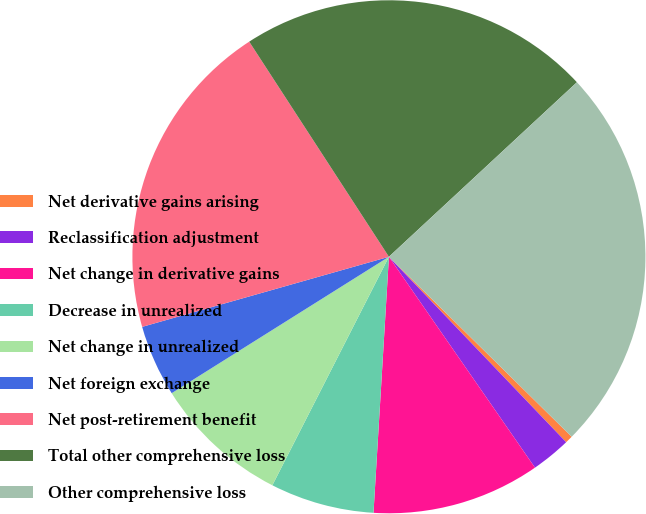<chart> <loc_0><loc_0><loc_500><loc_500><pie_chart><fcel>Net derivative gains arising<fcel>Reclassification adjustment<fcel>Net change in derivative gains<fcel>Decrease in unrealized<fcel>Net change in unrealized<fcel>Net foreign exchange<fcel>Net post-retirement benefit<fcel>Total other comprehensive loss<fcel>Other comprehensive loss<nl><fcel>0.48%<fcel>2.5%<fcel>10.6%<fcel>6.55%<fcel>8.57%<fcel>4.52%<fcel>20.24%<fcel>22.26%<fcel>24.29%<nl></chart> 